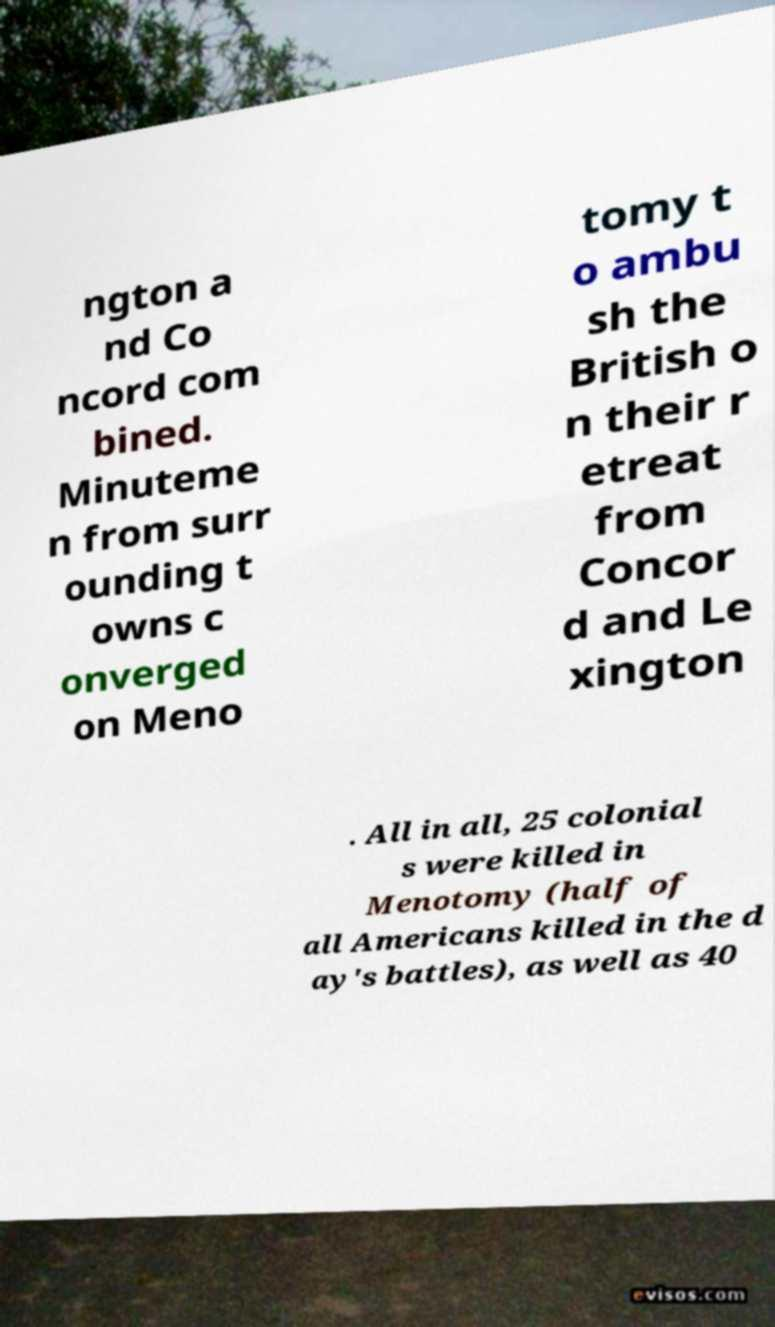For documentation purposes, I need the text within this image transcribed. Could you provide that? ngton a nd Co ncord com bined. Minuteme n from surr ounding t owns c onverged on Meno tomy t o ambu sh the British o n their r etreat from Concor d and Le xington . All in all, 25 colonial s were killed in Menotomy (half of all Americans killed in the d ay's battles), as well as 40 